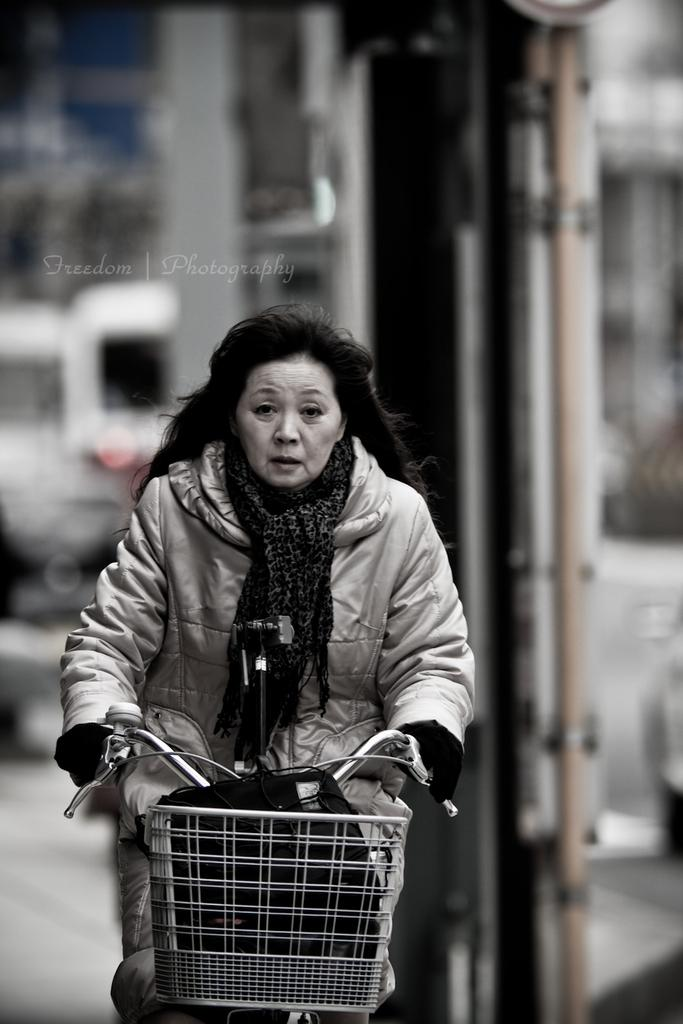Who is the main subject in the image? There is a woman in the image. What is the woman doing in the image? The woman is cycling a bicycle. Can you describe the background of the image? The background of the image is blurred. What is the color scheme of the image? The image is black and white. What type of ear is visible on the woman's bicycle in the image? There is no ear present on the woman's bicycle in the image. Can you tell me how many cubs are playing with the woman in the image? There are no cubs present in the image; it features a woman cycling a bicycle. 